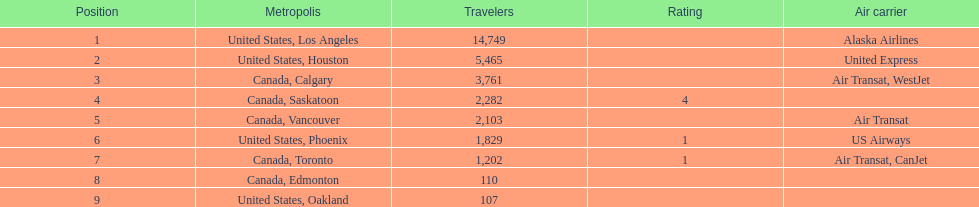How many more passengers flew to los angeles than to saskatoon from manzanillo airport in 2013? 12,467. 